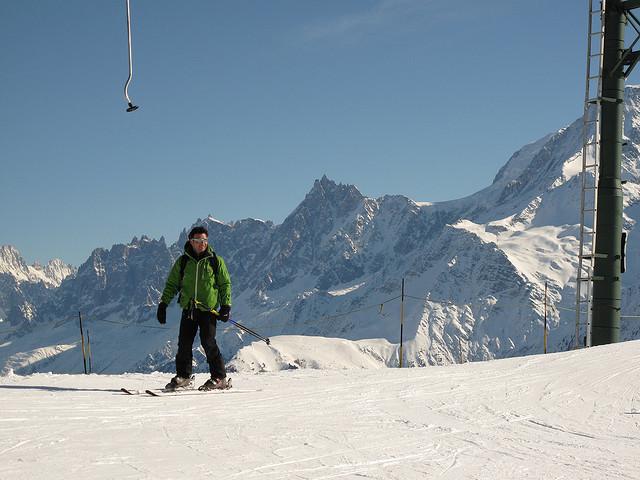Is this man at a high elevation?
Answer briefly. Yes. Is the man waving?
Give a very brief answer. No. Is the man attempting to ski?
Short answer required. Yes. How many people are wearing black pants?
Answer briefly. 1. Where is the man looking?
Quick response, please. Right. Is one of the man's arms at his side?
Be succinct. Yes. Does the man have adequate gear?
Quick response, please. Yes. 